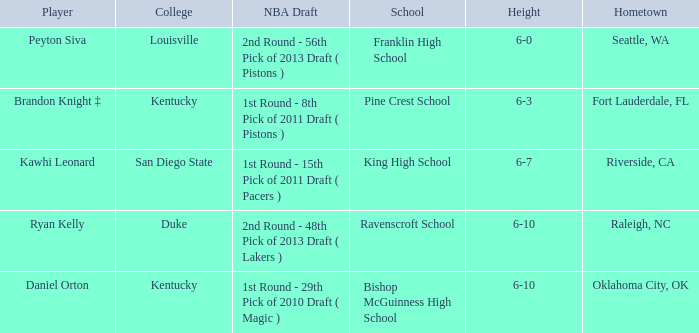Which school is in Riverside, CA? King High School. 